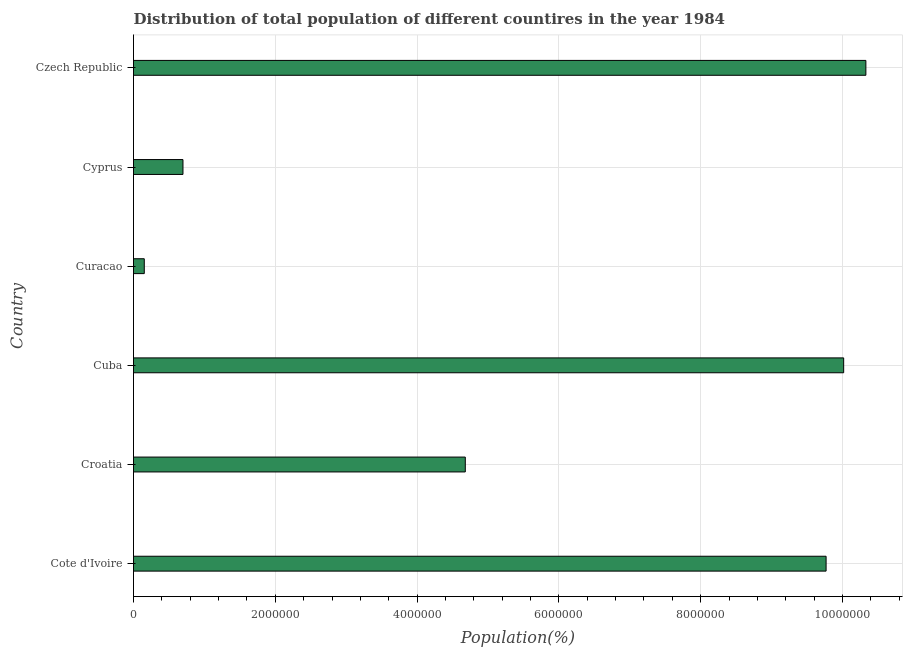Does the graph contain any zero values?
Your response must be concise. No. What is the title of the graph?
Your response must be concise. Distribution of total population of different countires in the year 1984. What is the label or title of the X-axis?
Ensure brevity in your answer.  Population(%). What is the population in Czech Republic?
Make the answer very short. 1.03e+07. Across all countries, what is the maximum population?
Offer a very short reply. 1.03e+07. Across all countries, what is the minimum population?
Keep it short and to the point. 1.52e+05. In which country was the population maximum?
Keep it short and to the point. Czech Republic. In which country was the population minimum?
Offer a very short reply. Curacao. What is the sum of the population?
Provide a succinct answer. 3.56e+07. What is the difference between the population in Cuba and Cyprus?
Your answer should be compact. 9.32e+06. What is the average population per country?
Keep it short and to the point. 5.94e+06. What is the median population?
Offer a terse response. 7.22e+06. What is the ratio of the population in Cuba to that in Cyprus?
Offer a terse response. 14.36. Is the difference between the population in Cote d'Ivoire and Croatia greater than the difference between any two countries?
Your response must be concise. No. What is the difference between the highest and the second highest population?
Provide a short and direct response. 3.13e+05. Is the sum of the population in Croatia and Cuba greater than the maximum population across all countries?
Provide a succinct answer. Yes. What is the difference between the highest and the lowest population?
Provide a short and direct response. 1.02e+07. Are all the bars in the graph horizontal?
Make the answer very short. Yes. What is the Population(%) in Cote d'Ivoire?
Provide a short and direct response. 9.77e+06. What is the Population(%) of Croatia?
Your answer should be compact. 4.68e+06. What is the Population(%) in Cuba?
Offer a terse response. 1.00e+07. What is the Population(%) of Curacao?
Keep it short and to the point. 1.52e+05. What is the Population(%) in Cyprus?
Make the answer very short. 6.98e+05. What is the Population(%) in Czech Republic?
Provide a succinct answer. 1.03e+07. What is the difference between the Population(%) in Cote d'Ivoire and Croatia?
Give a very brief answer. 5.09e+06. What is the difference between the Population(%) in Cote d'Ivoire and Cuba?
Provide a short and direct response. -2.48e+05. What is the difference between the Population(%) in Cote d'Ivoire and Curacao?
Offer a terse response. 9.62e+06. What is the difference between the Population(%) in Cote d'Ivoire and Cyprus?
Make the answer very short. 9.07e+06. What is the difference between the Population(%) in Cote d'Ivoire and Czech Republic?
Keep it short and to the point. -5.61e+05. What is the difference between the Population(%) in Croatia and Cuba?
Your answer should be very brief. -5.34e+06. What is the difference between the Population(%) in Croatia and Curacao?
Provide a short and direct response. 4.53e+06. What is the difference between the Population(%) in Croatia and Cyprus?
Ensure brevity in your answer.  3.98e+06. What is the difference between the Population(%) in Croatia and Czech Republic?
Ensure brevity in your answer.  -5.65e+06. What is the difference between the Population(%) in Cuba and Curacao?
Your answer should be very brief. 9.87e+06. What is the difference between the Population(%) in Cuba and Cyprus?
Provide a short and direct response. 9.32e+06. What is the difference between the Population(%) in Cuba and Czech Republic?
Give a very brief answer. -3.13e+05. What is the difference between the Population(%) in Curacao and Cyprus?
Offer a very short reply. -5.46e+05. What is the difference between the Population(%) in Curacao and Czech Republic?
Provide a succinct answer. -1.02e+07. What is the difference between the Population(%) in Cyprus and Czech Republic?
Provide a succinct answer. -9.63e+06. What is the ratio of the Population(%) in Cote d'Ivoire to that in Croatia?
Make the answer very short. 2.09. What is the ratio of the Population(%) in Cote d'Ivoire to that in Curacao?
Your response must be concise. 64.3. What is the ratio of the Population(%) in Cote d'Ivoire to that in Cyprus?
Make the answer very short. 14. What is the ratio of the Population(%) in Cote d'Ivoire to that in Czech Republic?
Your response must be concise. 0.95. What is the ratio of the Population(%) in Croatia to that in Cuba?
Offer a terse response. 0.47. What is the ratio of the Population(%) in Croatia to that in Curacao?
Your answer should be very brief. 30.8. What is the ratio of the Population(%) in Croatia to that in Cyprus?
Make the answer very short. 6.71. What is the ratio of the Population(%) in Croatia to that in Czech Republic?
Your response must be concise. 0.45. What is the ratio of the Population(%) in Cuba to that in Curacao?
Provide a short and direct response. 65.93. What is the ratio of the Population(%) in Cuba to that in Cyprus?
Ensure brevity in your answer.  14.36. What is the ratio of the Population(%) in Curacao to that in Cyprus?
Ensure brevity in your answer.  0.22. What is the ratio of the Population(%) in Curacao to that in Czech Republic?
Provide a succinct answer. 0.01. What is the ratio of the Population(%) in Cyprus to that in Czech Republic?
Keep it short and to the point. 0.07. 